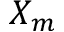Convert formula to latex. <formula><loc_0><loc_0><loc_500><loc_500>X _ { m }</formula> 